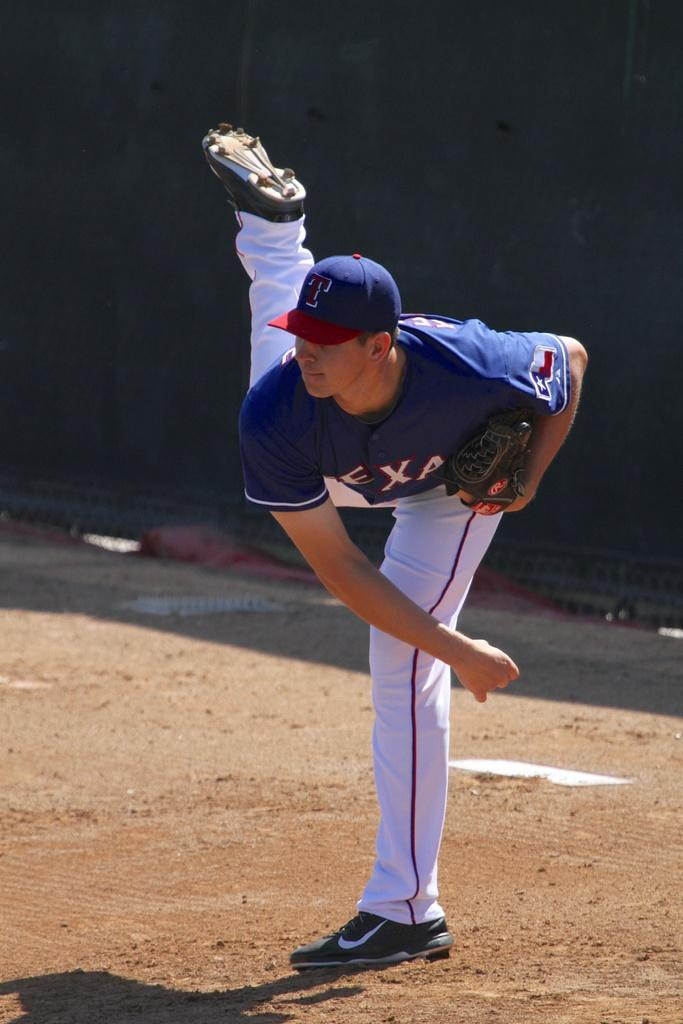<image>
Give a short and clear explanation of the subsequent image. a person with a T hat after throwing a baseball 